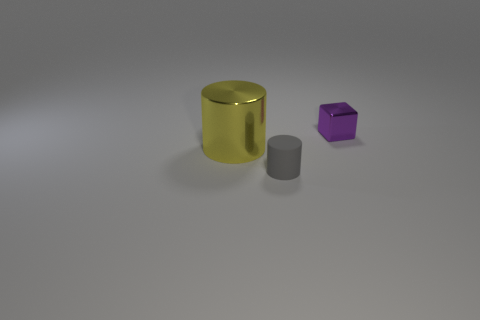Add 2 large cubes. How many objects exist? 5 Subtract all cubes. How many objects are left? 2 Subtract all large yellow shiny cylinders. Subtract all large purple metal spheres. How many objects are left? 2 Add 3 tiny gray cylinders. How many tiny gray cylinders are left? 4 Add 1 large green metallic balls. How many large green metallic balls exist? 1 Subtract 0 blue cylinders. How many objects are left? 3 